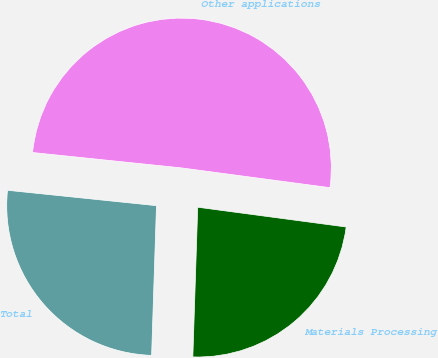Convert chart. <chart><loc_0><loc_0><loc_500><loc_500><pie_chart><fcel>Materials Processing<fcel>Other applications<fcel>Total<nl><fcel>23.41%<fcel>50.47%<fcel>26.12%<nl></chart> 